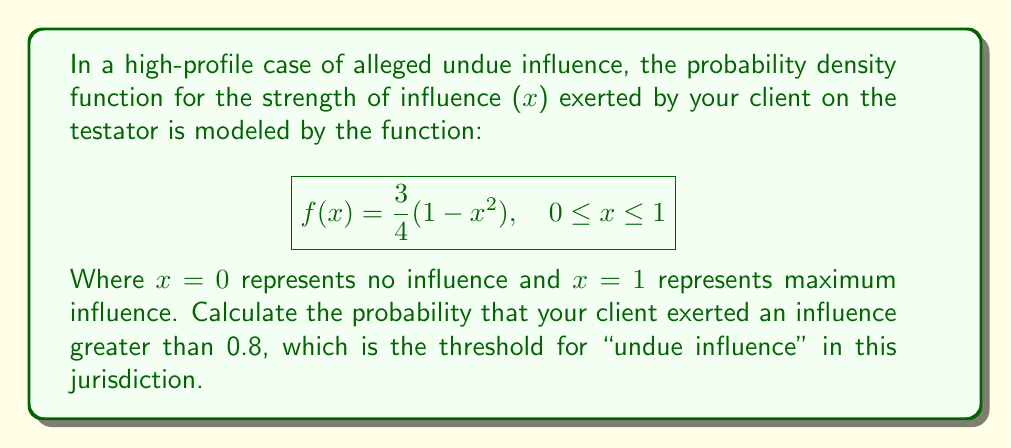Give your solution to this math problem. To solve this problem, we need to integrate the probability density function from 0.8 to 1, as this represents the probability of influence greater than 0.8.

1) The probability is given by the integral:

   $$P(x > 0.8) = \int_{0.8}^1 f(x) dx = \int_{0.8}^1 \frac{3}{4}(1-x^2) dx$$

2) Let's solve this integral:

   $$\int_{0.8}^1 \frac{3}{4}(1-x^2) dx = \frac{3}{4} \int_{0.8}^1 (1-x^2) dx$$

3) Integrate:

   $$\frac{3}{4} \left[x - \frac{x^3}{3}\right]_{0.8}^1$$

4) Evaluate the bounds:

   $$\frac{3}{4} \left[\left(1 - \frac{1^3}{3}\right) - \left(0.8 - \frac{0.8^3}{3}\right)\right]$$

5) Simplify:

   $$\frac{3}{4} \left[\left(1 - \frac{1}{3}\right) - \left(0.8 - \frac{0.512}{3}\right)\right]$$
   
   $$\frac{3}{4} \left[\frac{2}{3} - 0.8 + \frac{0.512}{3}\right]$$
   
   $$\frac{3}{4} \left[\frac{2}{3} - \frac{2.4}{3} + \frac{0.512}{3}\right]$$
   
   $$\frac{3}{4} \cdot \frac{0.112}{3} = 0.028$$

Thus, the probability that your client exerted an influence greater than 0.8 is approximately 0.028 or 2.8%.
Answer: 0.028 or 2.8% 